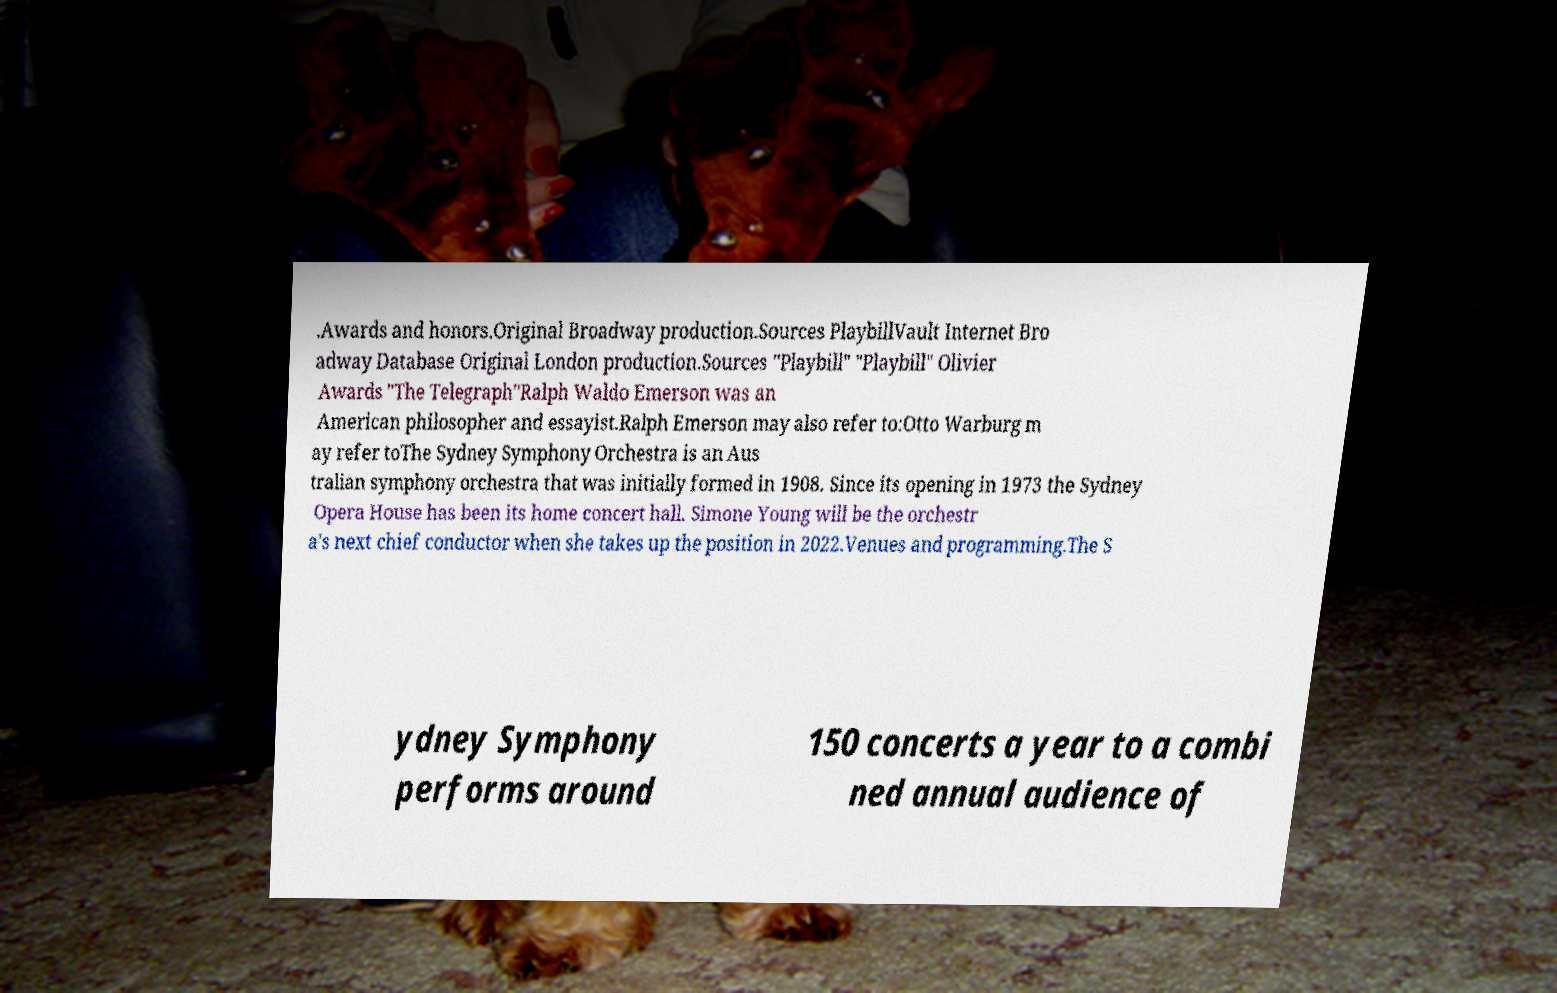Could you extract and type out the text from this image? .Awards and honors.Original Broadway production.Sources PlaybillVault Internet Bro adway Database Original London production.Sources "Playbill" "Playbill" Olivier Awards "The Telegraph"Ralph Waldo Emerson was an American philosopher and essayist.Ralph Emerson may also refer to:Otto Warburg m ay refer toThe Sydney Symphony Orchestra is an Aus tralian symphony orchestra that was initially formed in 1908. Since its opening in 1973 the Sydney Opera House has been its home concert hall. Simone Young will be the orchestr a's next chief conductor when she takes up the position in 2022.Venues and programming.The S ydney Symphony performs around 150 concerts a year to a combi ned annual audience of 